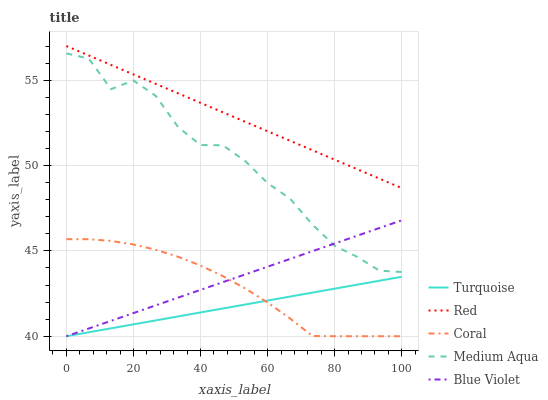Does Turquoise have the minimum area under the curve?
Answer yes or no. Yes. Does Red have the maximum area under the curve?
Answer yes or no. Yes. Does Medium Aqua have the minimum area under the curve?
Answer yes or no. No. Does Medium Aqua have the maximum area under the curve?
Answer yes or no. No. Is Turquoise the smoothest?
Answer yes or no. Yes. Is Medium Aqua the roughest?
Answer yes or no. Yes. Is Medium Aqua the smoothest?
Answer yes or no. No. Is Turquoise the roughest?
Answer yes or no. No. Does Blue Violet have the lowest value?
Answer yes or no. Yes. Does Medium Aqua have the lowest value?
Answer yes or no. No. Does Red have the highest value?
Answer yes or no. Yes. Does Medium Aqua have the highest value?
Answer yes or no. No. Is Coral less than Red?
Answer yes or no. Yes. Is Medium Aqua greater than Turquoise?
Answer yes or no. Yes. Does Coral intersect Blue Violet?
Answer yes or no. Yes. Is Coral less than Blue Violet?
Answer yes or no. No. Is Coral greater than Blue Violet?
Answer yes or no. No. Does Coral intersect Red?
Answer yes or no. No. 